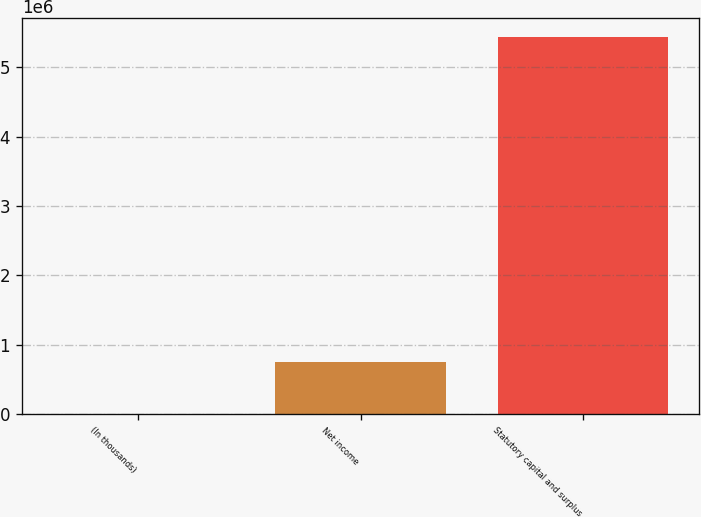Convert chart. <chart><loc_0><loc_0><loc_500><loc_500><bar_chart><fcel>(In thousands)<fcel>Net income<fcel>Statutory capital and surplus<nl><fcel>2014<fcel>757010<fcel>5.43806e+06<nl></chart> 